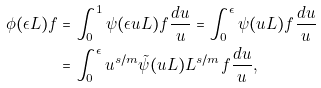Convert formula to latex. <formula><loc_0><loc_0><loc_500><loc_500>\phi ( \epsilon L ) f & = \int _ { 0 } ^ { 1 } \psi ( \epsilon u L ) f \frac { d u } { u } = \int _ { 0 } ^ { \epsilon } \psi ( u L ) f \frac { d u } { u } \\ & = \int _ { 0 } ^ { \epsilon } u ^ { s / m } \tilde { \psi } ( u L ) L ^ { s / m } f \frac { d u } { u } ,</formula> 